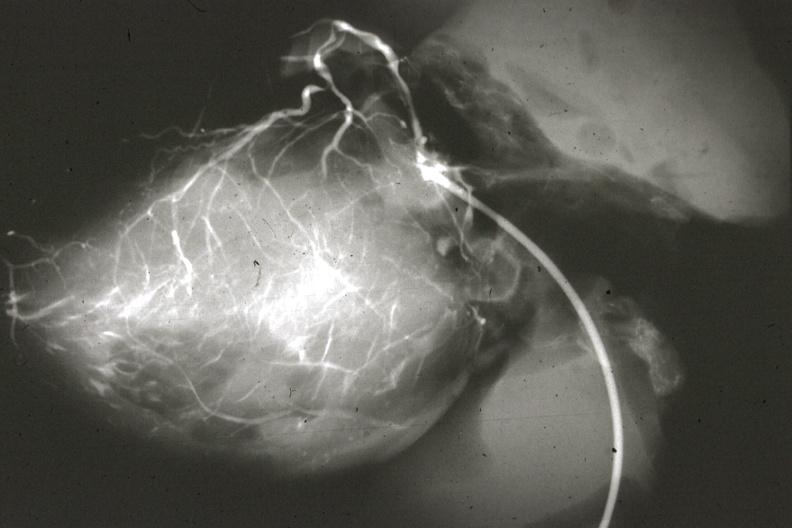what left from pulmonary artery?
Answer the question using a single word or phrase. Anomalous origin 